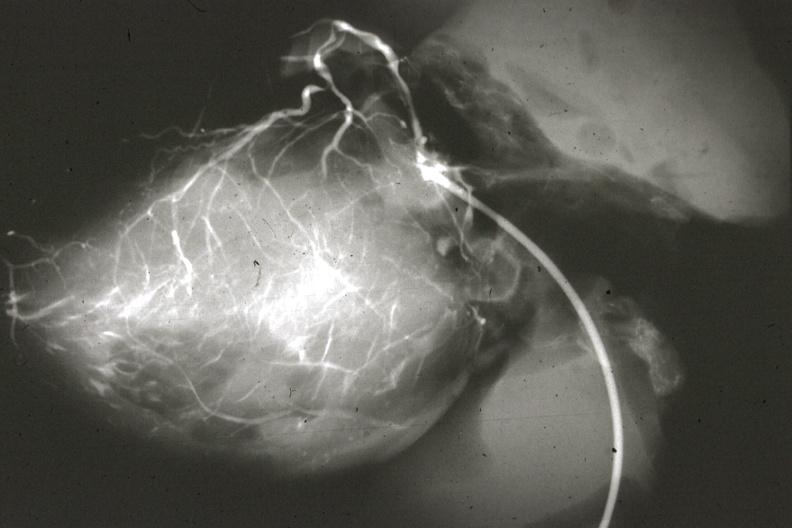what left from pulmonary artery?
Answer the question using a single word or phrase. Anomalous origin 